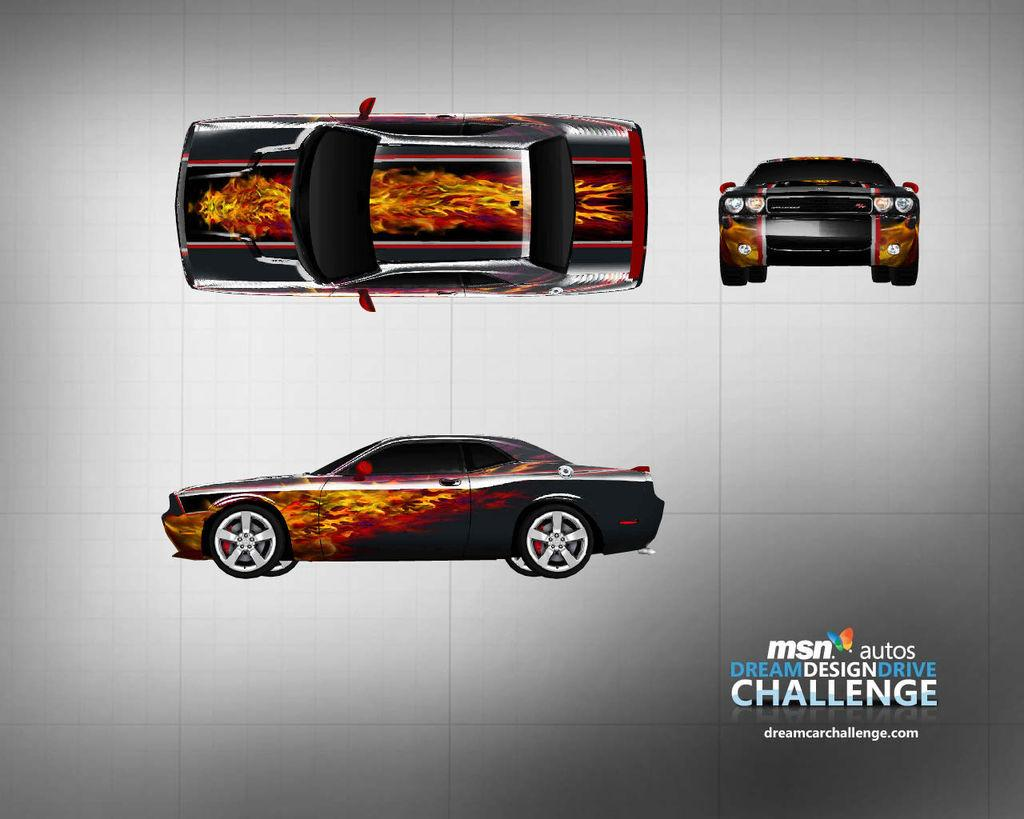What type of image is being described? The image is animated and edited. What additional information is present on the image? There is text written on the image. What is one of the main subjects depicted in the image? There are images of a car in the image. What type of bone can be seen in the middle of the image? There is no bone present in the image; it features an animated and edited scene with text and images of a car. What language is the text written in on the image? The provided facts do not mention the language of the text on the image, so it cannot be determined from the information given. 